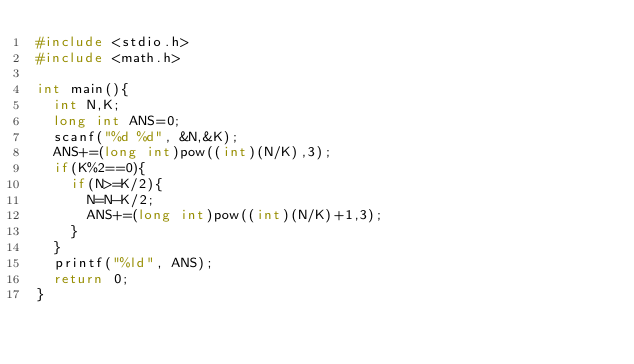Convert code to text. <code><loc_0><loc_0><loc_500><loc_500><_C_>#include <stdio.h>
#include <math.h>

int main(){
  int N,K;
  long int ANS=0;
  scanf("%d %d", &N,&K);
  ANS+=(long int)pow((int)(N/K),3);
  if(K%2==0){
    if(N>=K/2){
      N=N-K/2;
      ANS+=(long int)pow((int)(N/K)+1,3);
    }
  }
  printf("%ld", ANS);
  return 0;
}
    
</code> 